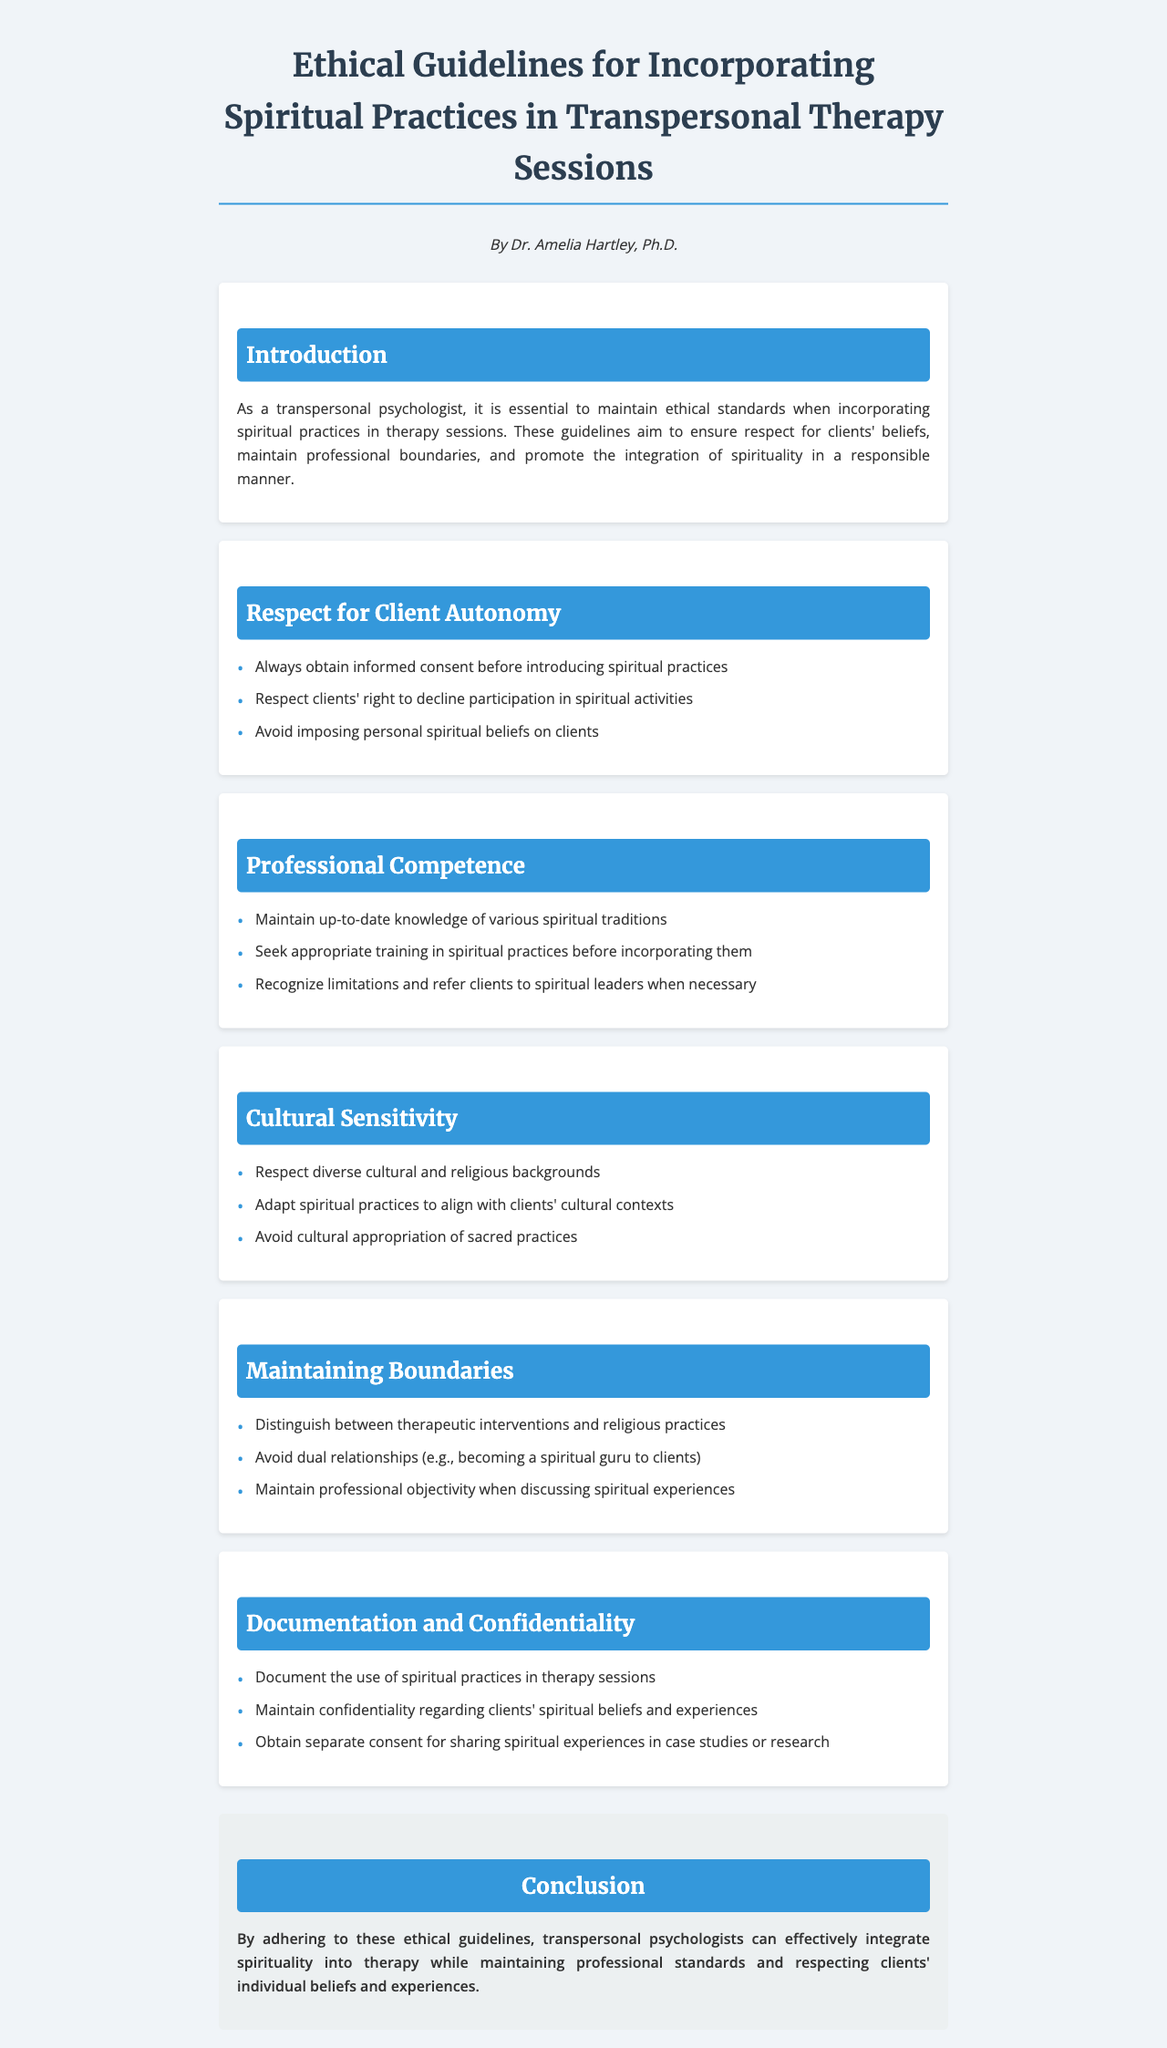What is the title of the document? The title is specified at the top of the document and indicates the subject matter covered.
Answer: Ethical Guidelines for Incorporating Spiritual Practices in Transpersonal Therapy Sessions Who is the author of the document? The author is mentioned under the title and provides credibility to the guidelines presented.
Answer: Dr. Amelia Hartley, Ph.D What section discusses client consent? The section specifically addressing the rights of clients in relation to their participation in spiritual practices includes this topic.
Answer: Respect for Client Autonomy How many main sections are in the document? Counting the main thematic divisions provided gives a clear overview of the document's structure.
Answer: Five What is one responsibility of a transpersonal psychologist mentioned in the Professional Competence section? The section outlines specific competences expected of psychologists when incorporating spiritual practices, indicating necessary actions to maintain professionalism.
Answer: Seek appropriate training in spiritual practices before incorporating them Name one aspect discussed under Cultural Sensitivity. This section emphasizes the importance of understanding and respecting different cultural contexts in therapy, detailing specific considerations.
Answer: Avoid cultural appropriation of sacred practices What must be documented as per the guidelines? The guidelines stress the need for specific documentation related to spiritual practices used during therapy sessions for ethical compliance.
Answer: The use of spiritual practices in therapy sessions What is a potential consequence of dual relationships mentioned in the Maintaining Boundaries section? The document highlights the importance of maintaining professional boundaries to avoid conflicts of interest or ethical dilemmas, which can arise from dual relationships.
Answer: Becoming a spiritual guru to clients 